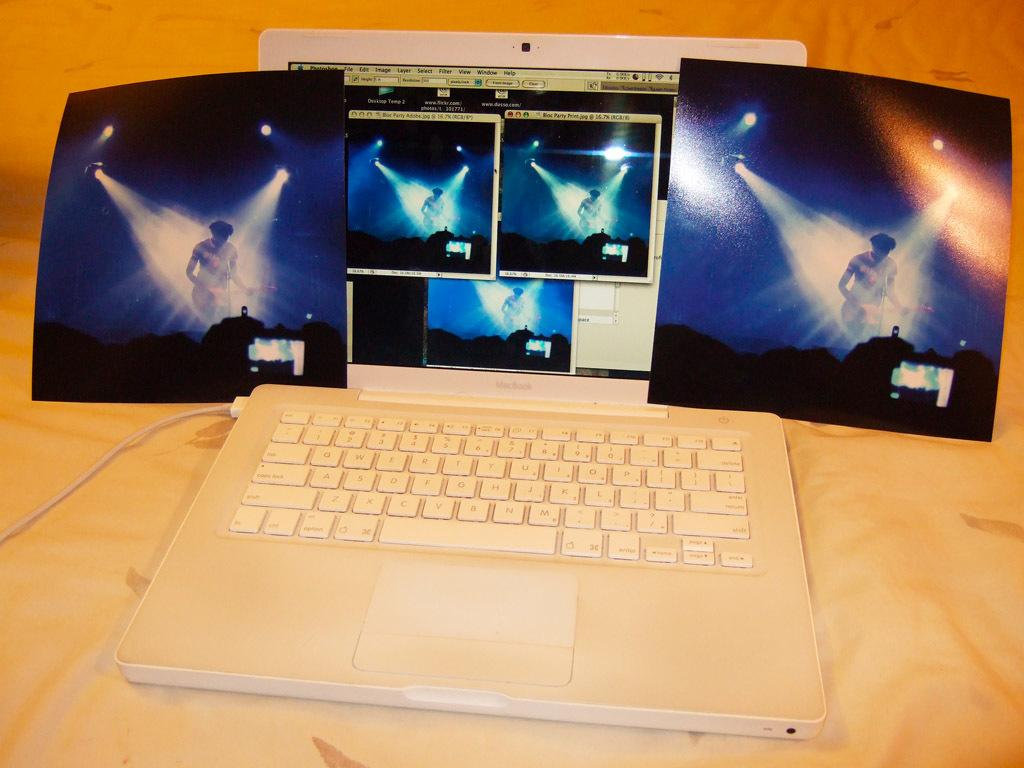What is the main object in the center of the image? There is a laptop in the center of the image. What else can be seen in the image besides the laptop? There are pictures placed on a cloth in the image. What type of fiction is being read on the laptop in the image? There is no indication in the image that the laptop is being used to read fiction, as the focus is on the laptop itself and the pictures on the cloth. 